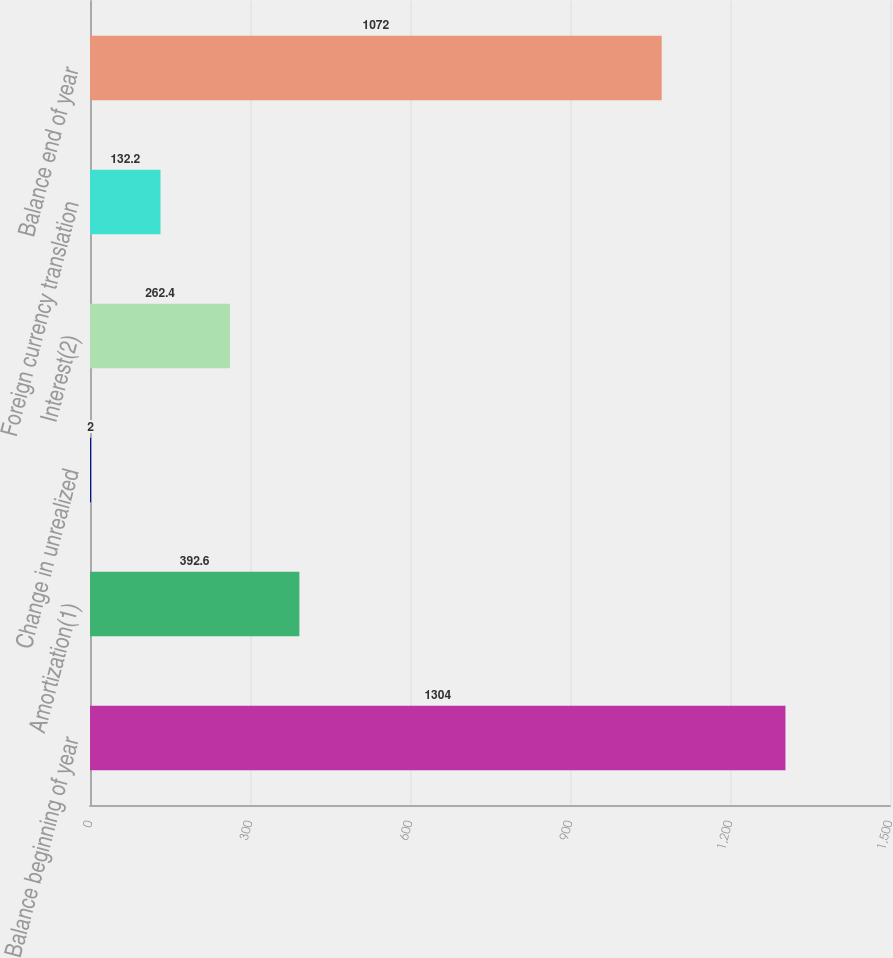<chart> <loc_0><loc_0><loc_500><loc_500><bar_chart><fcel>Balance beginning of year<fcel>Amortization(1)<fcel>Change in unrealized<fcel>Interest(2)<fcel>Foreign currency translation<fcel>Balance end of year<nl><fcel>1304<fcel>392.6<fcel>2<fcel>262.4<fcel>132.2<fcel>1072<nl></chart> 